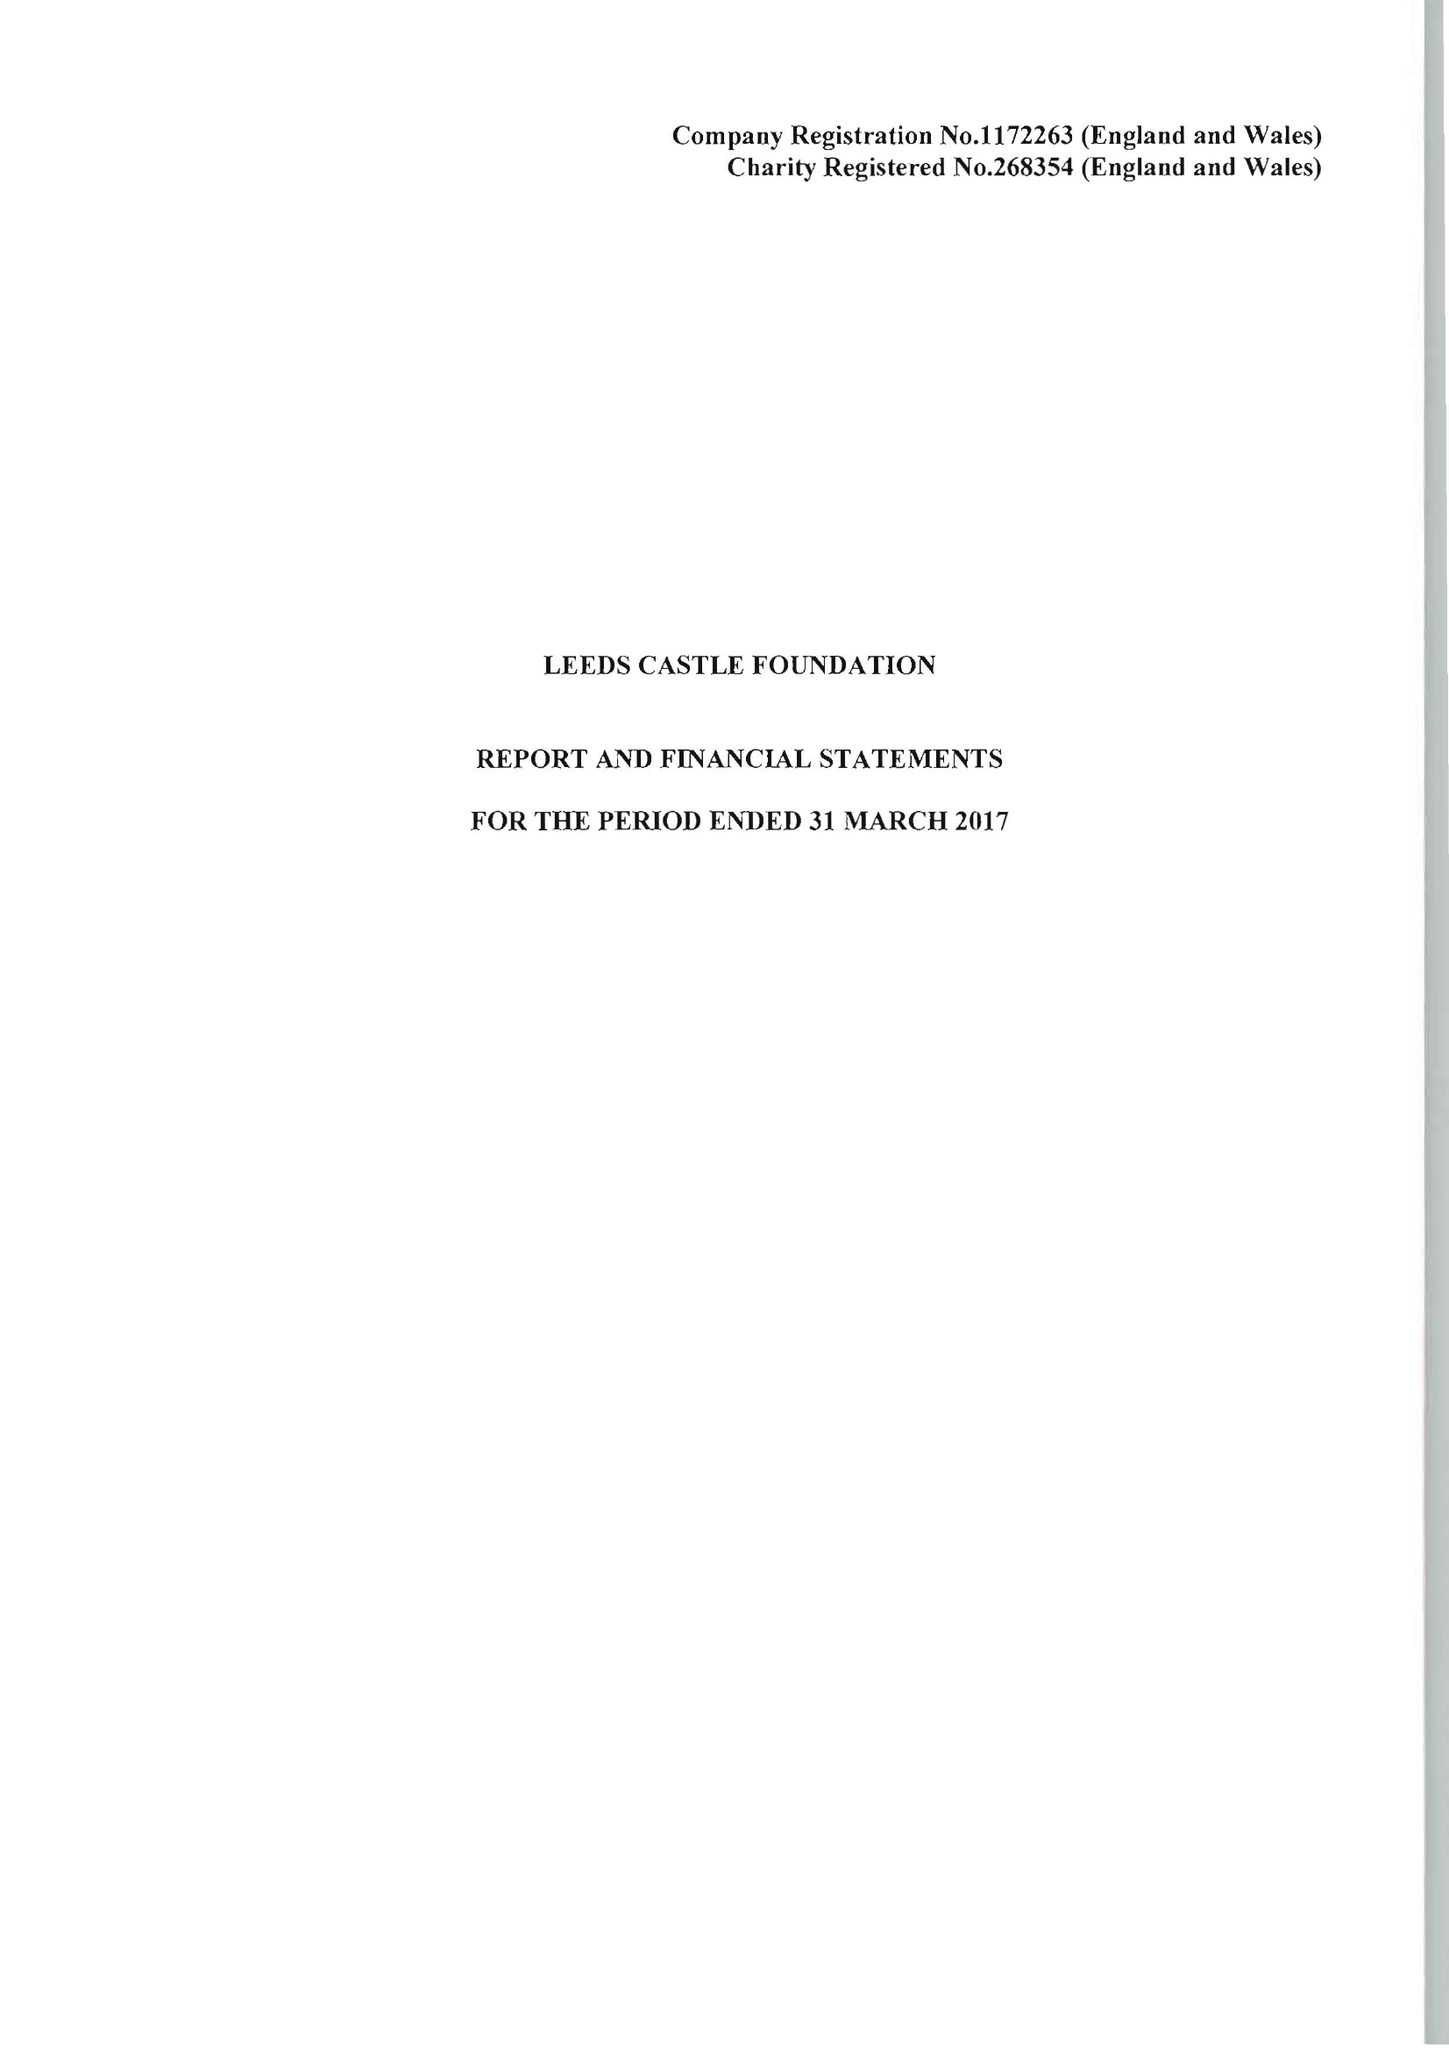What is the value for the charity_name?
Answer the question using a single word or phrase. Leeds Castle Foundation 